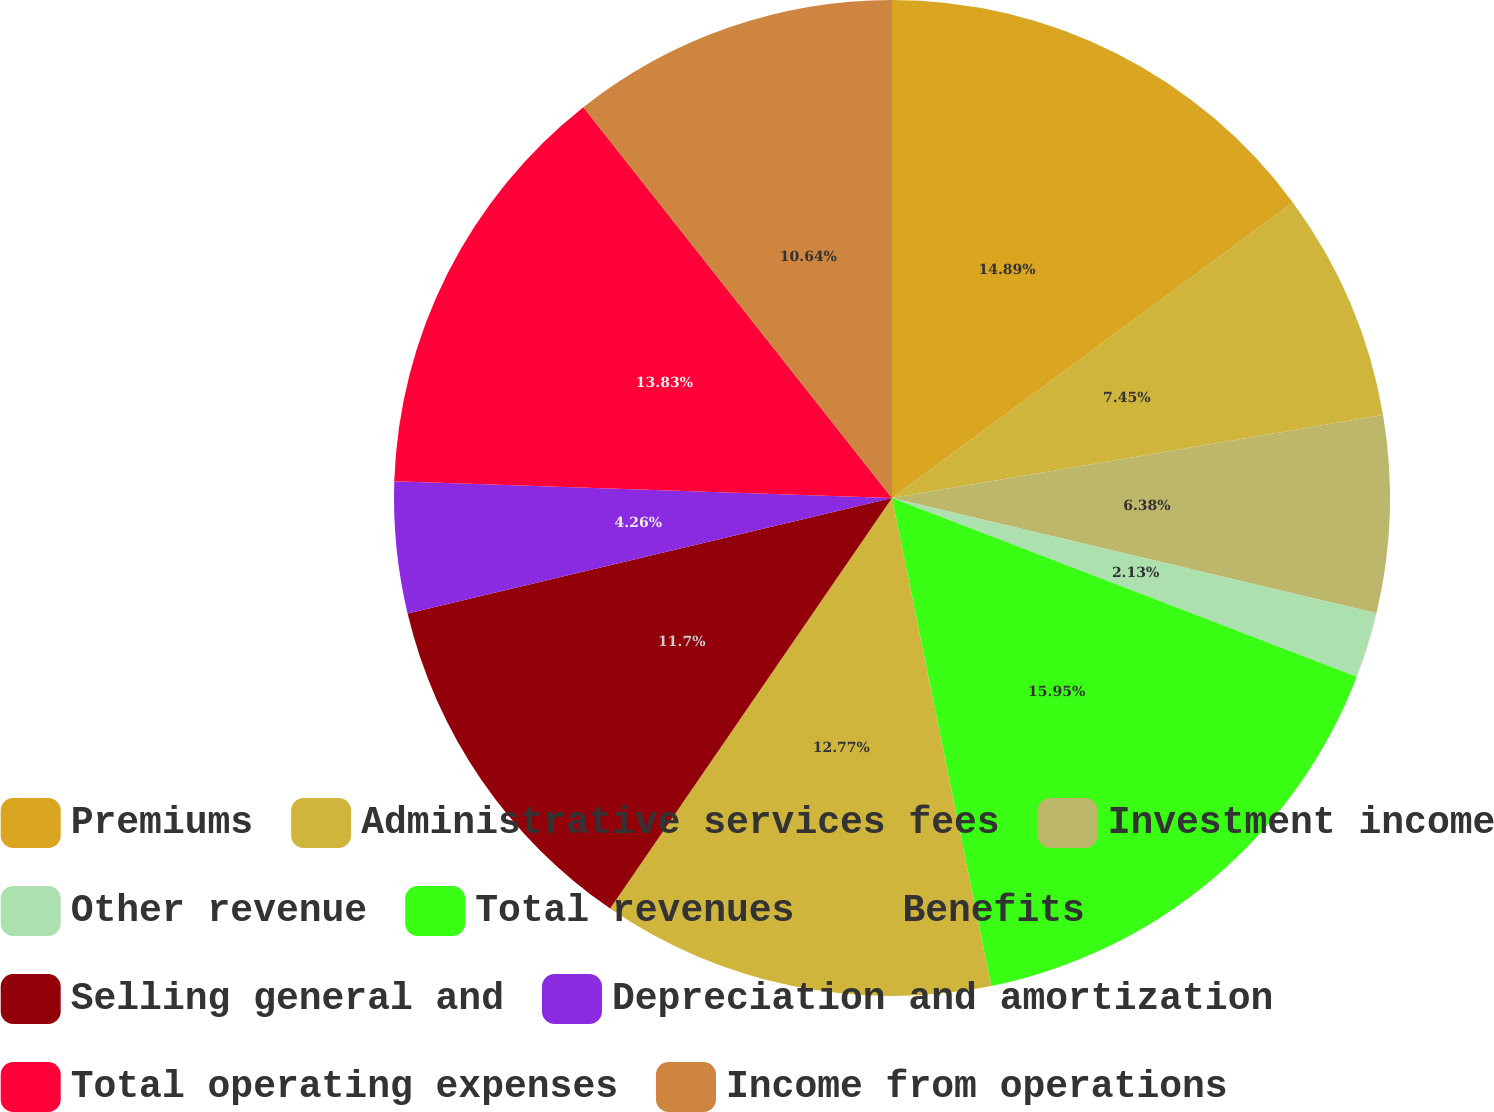Convert chart. <chart><loc_0><loc_0><loc_500><loc_500><pie_chart><fcel>Premiums<fcel>Administrative services fees<fcel>Investment income<fcel>Other revenue<fcel>Total revenues<fcel>Benefits<fcel>Selling general and<fcel>Depreciation and amortization<fcel>Total operating expenses<fcel>Income from operations<nl><fcel>14.89%<fcel>7.45%<fcel>6.38%<fcel>2.13%<fcel>15.96%<fcel>12.77%<fcel>11.7%<fcel>4.26%<fcel>13.83%<fcel>10.64%<nl></chart> 